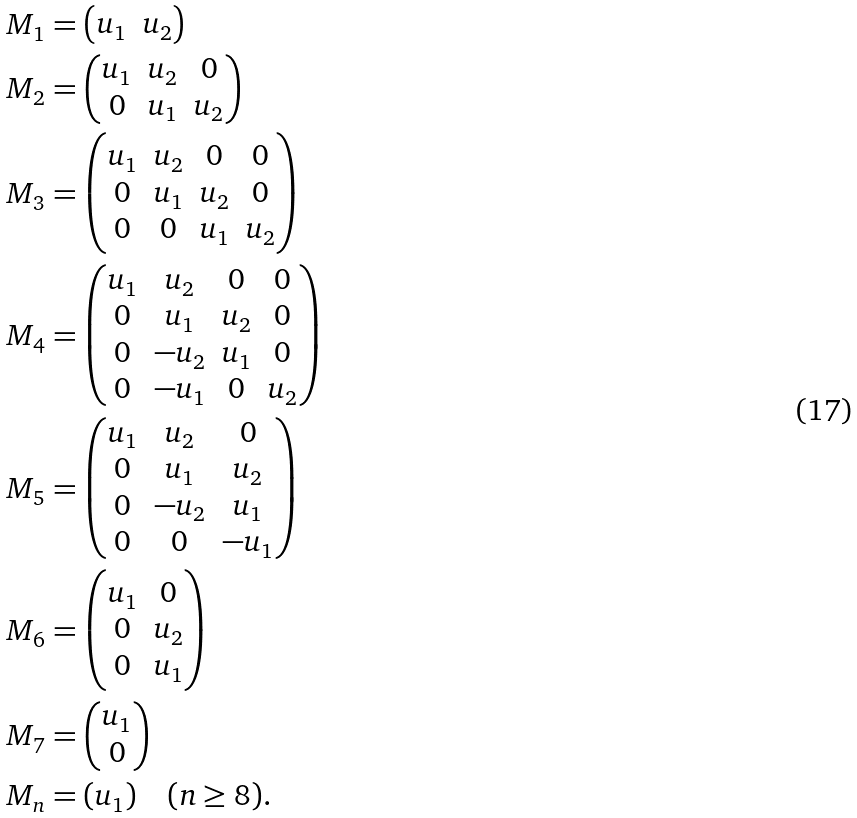Convert formula to latex. <formula><loc_0><loc_0><loc_500><loc_500>M _ { 1 } & = \begin{pmatrix} u _ { 1 } & u _ { 2 } \end{pmatrix} \\ M _ { 2 } & = \begin{pmatrix} u _ { 1 } & u _ { 2 } & 0 \\ 0 & u _ { 1 } & u _ { 2 } \end{pmatrix} \\ M _ { 3 } & = \begin{pmatrix} u _ { 1 } & u _ { 2 } & 0 & 0 \\ 0 & u _ { 1 } & u _ { 2 } & 0 \\ 0 & 0 & u _ { 1 } & u _ { 2 } \end{pmatrix} \\ M _ { 4 } & = \begin{pmatrix} u _ { 1 } & u _ { 2 } & 0 & 0 \\ 0 & u _ { 1 } & u _ { 2 } & 0 \\ 0 & - u _ { 2 } & u _ { 1 } & 0 \\ 0 & - u _ { 1 } & 0 & u _ { 2 } \end{pmatrix} \\ M _ { 5 } & = \begin{pmatrix} u _ { 1 } & u _ { 2 } & 0 \\ 0 & u _ { 1 } & u _ { 2 } \\ 0 & - u _ { 2 } & u _ { 1 } \\ 0 & 0 & - u _ { 1 } \end{pmatrix} \\ M _ { 6 } & = \begin{pmatrix} u _ { 1 } & 0 \\ 0 & u _ { 2 } \\ 0 & u _ { 1 } \end{pmatrix} \\ M _ { 7 } & = \begin{pmatrix} u _ { 1 } \\ 0 \end{pmatrix} \\ M _ { n } & = ( u _ { 1 } ) \quad ( n \geq 8 ) .</formula> 